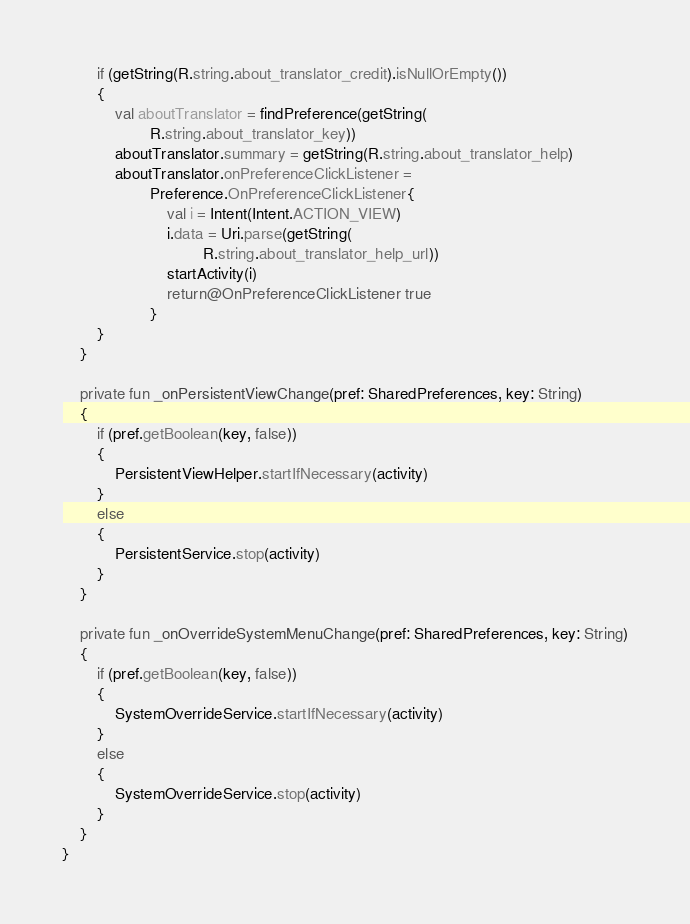Convert code to text. <code><loc_0><loc_0><loc_500><loc_500><_Kotlin_>		if (getString(R.string.about_translator_credit).isNullOrEmpty())
		{
			val aboutTranslator = findPreference(getString(
					R.string.about_translator_key))
			aboutTranslator.summary = getString(R.string.about_translator_help)
			aboutTranslator.onPreferenceClickListener =
					Preference.OnPreferenceClickListener{
						val i = Intent(Intent.ACTION_VIEW)
						i.data = Uri.parse(getString(
								R.string.about_translator_help_url))
						startActivity(i)
						return@OnPreferenceClickListener true
					}
		}
	}

	private fun _onPersistentViewChange(pref: SharedPreferences, key: String)
	{
		if (pref.getBoolean(key, false))
		{
			PersistentViewHelper.startIfNecessary(activity)
		}
		else
		{
			PersistentService.stop(activity)
		}
	}

	private fun _onOverrideSystemMenuChange(pref: SharedPreferences, key: String)
	{
		if (pref.getBoolean(key, false))
		{
			SystemOverrideService.startIfNecessary(activity)
		}
		else
		{
			SystemOverrideService.stop(activity)
		}
	}
}
</code> 